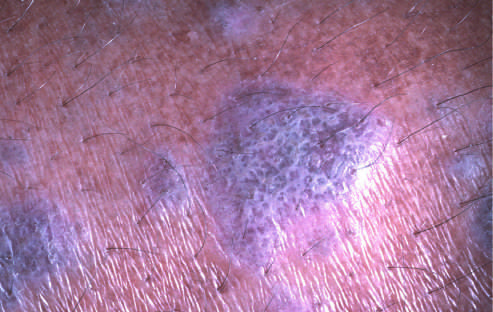re flat-topped pink-purple polygonal papule with white lacelike markings referred to as wickham striae?
Answer the question using a single word or phrase. Yes 